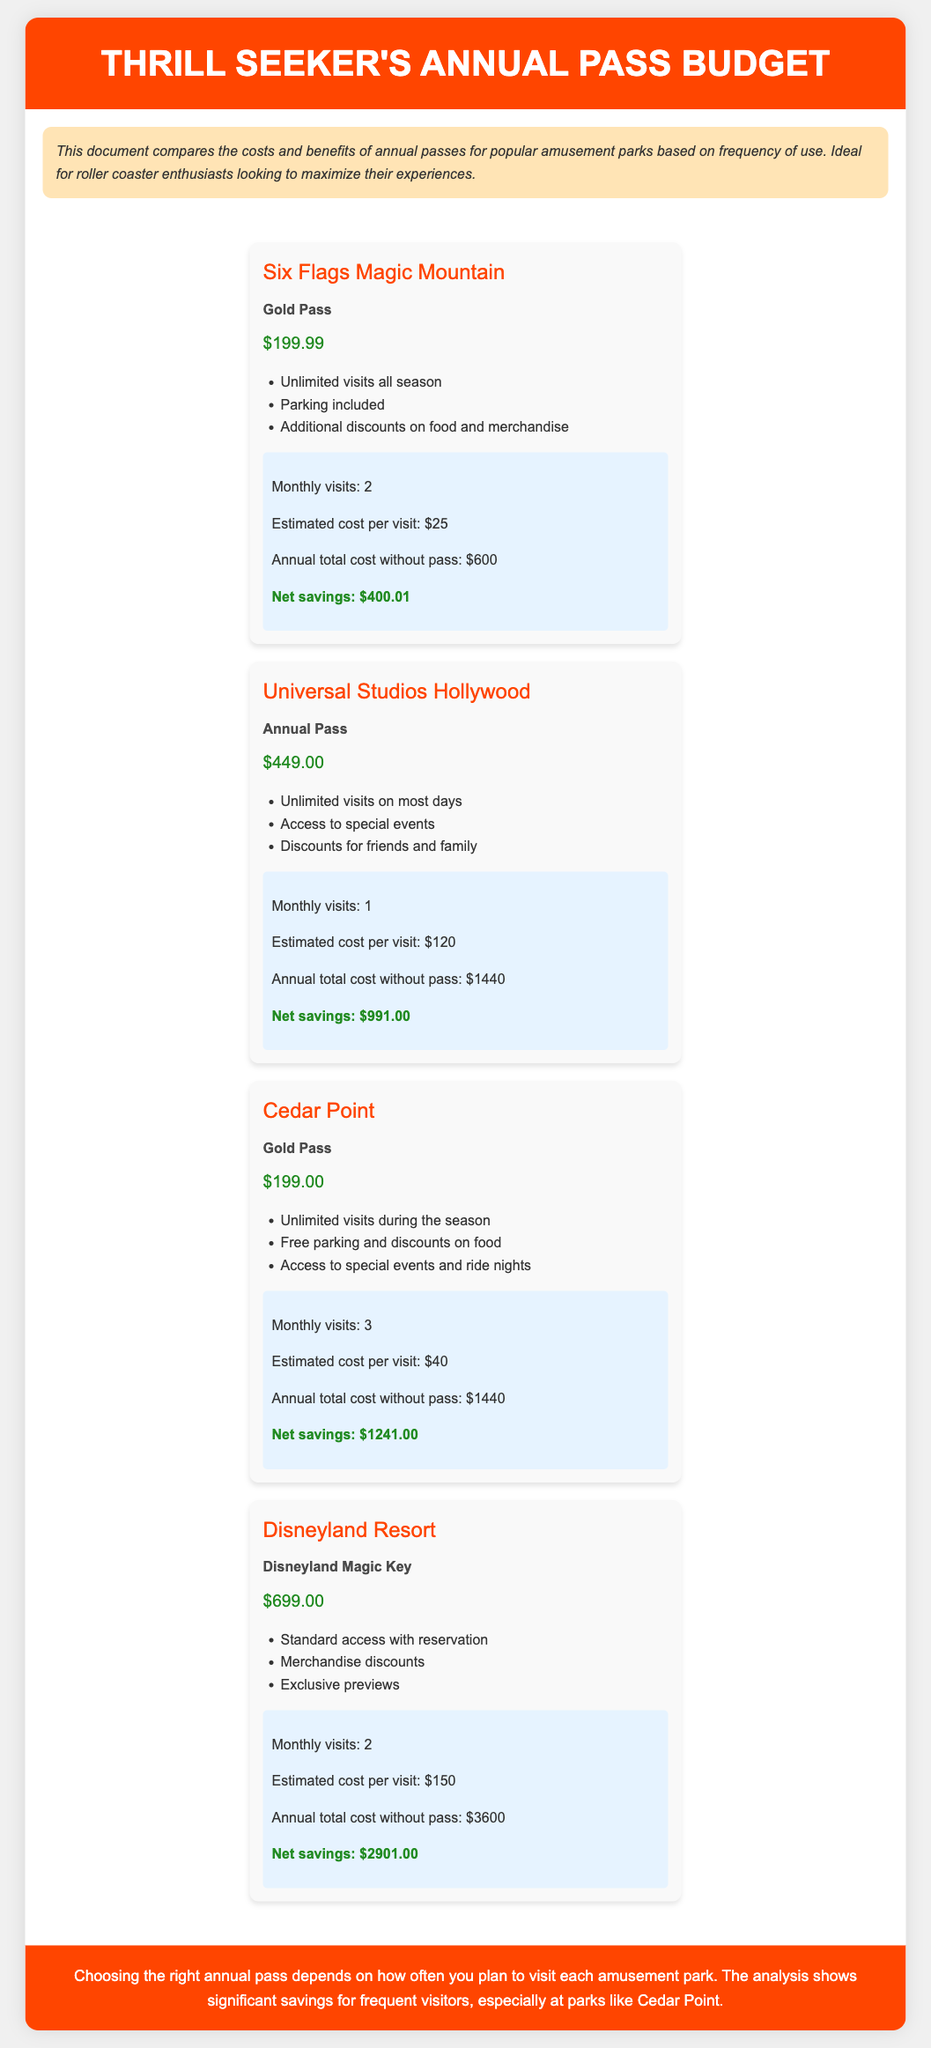what is the cost of the Gold Pass at Six Flags Magic Mountain? The document states that the Gold Pass at Six Flags Magic Mountain costs $199.99.
Answer: $199.99 how many monthly visits does the Cedar Point Gold Pass support? The usage stats for Cedar Point indicate that the Gold Pass allows for 3 monthly visits.
Answer: 3 what is the net savings with the Universal Studios Hollywood Annual Pass? The estimated net savings with the Universal Studios Hollywood Annual Pass is provided in the usage stats, which is $991.00.
Answer: $991.00 which park has the highest annual pass cost? Based on the document, Disneyland Resort has the highest annual pass cost at $699.00.
Answer: $699.00 how much might a visitor save with the Disneyland Magic Key? The document details the net savings with the Disneyland Magic Key, which is $2901.00.
Answer: $2901.00 what additional benefits come with the Cedar Point Gold Pass? The Cedar Point Gold Pass includes free parking and discounts on food, as listed in the benefits section.
Answer: Free parking and discounts on food which amusement park offers unlimited visits all season for $199.00? The document specifies that Cedar Point offers unlimited visits all season for a Gold Pass costing $199.00.
Answer: Cedar Point how many monthly visits are required for the Disneyland Resort to see savings? To realize savings, the Disneyland Resort pass requires 2 monthly visits as mentioned in the usage stats.
Answer: 2 